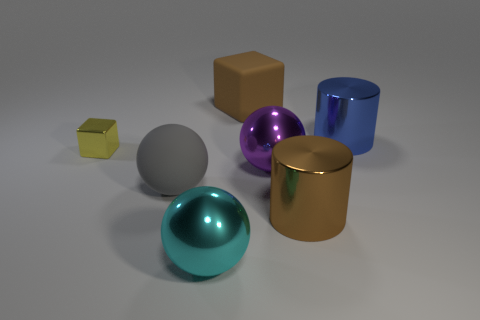Does the big matte object that is in front of the large purple ball have the same color as the large matte cube?
Give a very brief answer. No. Does the cyan object have the same material as the brown thing that is behind the brown metal cylinder?
Your answer should be very brief. No. There is a object that is on the left side of the gray matte sphere; what shape is it?
Your response must be concise. Cube. What number of other things are there of the same material as the cyan object
Provide a succinct answer. 4. What size is the brown matte cube?
Offer a terse response. Large. What number of other things are there of the same color as the large rubber cube?
Your answer should be very brief. 1. The large metallic thing that is both behind the big cyan metallic ball and left of the big brown shiny cylinder is what color?
Your answer should be very brief. Purple. What number of yellow metal cylinders are there?
Provide a short and direct response. 0. Is the material of the tiny thing the same as the large cyan sphere?
Offer a terse response. Yes. What shape is the big brown thing that is on the left side of the large shiny sphere behind the metal cylinder that is to the left of the big blue metal object?
Provide a short and direct response. Cube. 